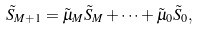Convert formula to latex. <formula><loc_0><loc_0><loc_500><loc_500>\tilde { S } _ { M + 1 } = \tilde { \mu } _ { M } \tilde { S } _ { M } + \dots + \tilde { \mu } _ { 0 } \tilde { S } _ { 0 } ,</formula> 